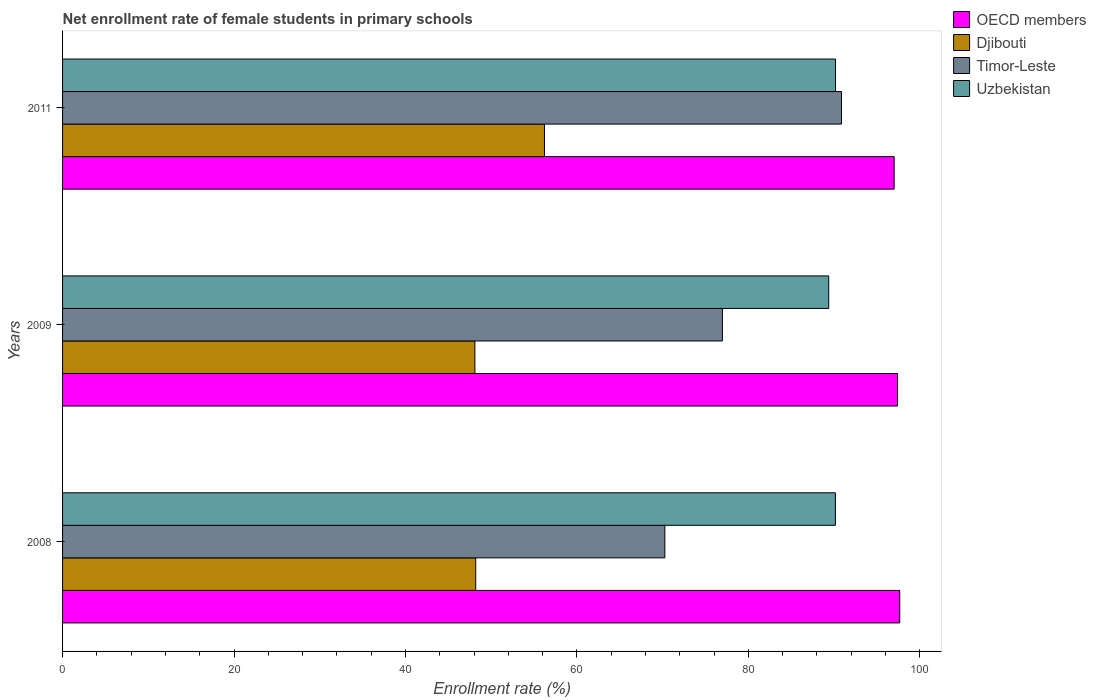How many groups of bars are there?
Provide a short and direct response. 3. Are the number of bars on each tick of the Y-axis equal?
Make the answer very short. Yes. How many bars are there on the 1st tick from the bottom?
Provide a short and direct response. 4. What is the net enrollment rate of female students in primary schools in Djibouti in 2011?
Your response must be concise. 56.22. Across all years, what is the maximum net enrollment rate of female students in primary schools in Timor-Leste?
Provide a succinct answer. 90.86. Across all years, what is the minimum net enrollment rate of female students in primary schools in Timor-Leste?
Keep it short and to the point. 70.26. What is the total net enrollment rate of female students in primary schools in Djibouti in the graph?
Offer a terse response. 152.51. What is the difference between the net enrollment rate of female students in primary schools in Djibouti in 2008 and that in 2011?
Make the answer very short. -8.02. What is the difference between the net enrollment rate of female students in primary schools in Timor-Leste in 2011 and the net enrollment rate of female students in primary schools in Djibouti in 2008?
Offer a terse response. 42.67. What is the average net enrollment rate of female students in primary schools in OECD members per year?
Provide a short and direct response. 97.36. In the year 2009, what is the difference between the net enrollment rate of female students in primary schools in Djibouti and net enrollment rate of female students in primary schools in Uzbekistan?
Give a very brief answer. -41.27. What is the ratio of the net enrollment rate of female students in primary schools in Uzbekistan in 2008 to that in 2009?
Ensure brevity in your answer.  1.01. What is the difference between the highest and the second highest net enrollment rate of female students in primary schools in OECD members?
Provide a succinct answer. 0.25. What is the difference between the highest and the lowest net enrollment rate of female students in primary schools in Djibouti?
Keep it short and to the point. 8.12. Is the sum of the net enrollment rate of female students in primary schools in OECD members in 2008 and 2011 greater than the maximum net enrollment rate of female students in primary schools in Djibouti across all years?
Your response must be concise. Yes. What does the 3rd bar from the top in 2008 represents?
Your answer should be very brief. Djibouti. What does the 3rd bar from the bottom in 2009 represents?
Provide a short and direct response. Timor-Leste. How many bars are there?
Your response must be concise. 12. What is the difference between two consecutive major ticks on the X-axis?
Make the answer very short. 20. Are the values on the major ticks of X-axis written in scientific E-notation?
Offer a terse response. No. Does the graph contain any zero values?
Make the answer very short. No. How are the legend labels stacked?
Your response must be concise. Vertical. What is the title of the graph?
Your response must be concise. Net enrollment rate of female students in primary schools. Does "East Asia (all income levels)" appear as one of the legend labels in the graph?
Provide a succinct answer. No. What is the label or title of the X-axis?
Your response must be concise. Enrollment rate (%). What is the label or title of the Y-axis?
Offer a very short reply. Years. What is the Enrollment rate (%) of OECD members in 2008?
Offer a very short reply. 97.66. What is the Enrollment rate (%) of Djibouti in 2008?
Give a very brief answer. 48.19. What is the Enrollment rate (%) in Timor-Leste in 2008?
Offer a very short reply. 70.26. What is the Enrollment rate (%) of Uzbekistan in 2008?
Offer a very short reply. 90.15. What is the Enrollment rate (%) in OECD members in 2009?
Offer a terse response. 97.4. What is the Enrollment rate (%) in Djibouti in 2009?
Offer a very short reply. 48.1. What is the Enrollment rate (%) in Timor-Leste in 2009?
Your answer should be compact. 76.97. What is the Enrollment rate (%) of Uzbekistan in 2009?
Your response must be concise. 89.37. What is the Enrollment rate (%) in OECD members in 2011?
Your answer should be very brief. 97.01. What is the Enrollment rate (%) of Djibouti in 2011?
Your answer should be very brief. 56.22. What is the Enrollment rate (%) in Timor-Leste in 2011?
Offer a very short reply. 90.86. What is the Enrollment rate (%) of Uzbekistan in 2011?
Provide a short and direct response. 90.17. Across all years, what is the maximum Enrollment rate (%) of OECD members?
Your response must be concise. 97.66. Across all years, what is the maximum Enrollment rate (%) of Djibouti?
Provide a short and direct response. 56.22. Across all years, what is the maximum Enrollment rate (%) in Timor-Leste?
Your answer should be compact. 90.86. Across all years, what is the maximum Enrollment rate (%) of Uzbekistan?
Your answer should be compact. 90.17. Across all years, what is the minimum Enrollment rate (%) of OECD members?
Offer a terse response. 97.01. Across all years, what is the minimum Enrollment rate (%) in Djibouti?
Make the answer very short. 48.1. Across all years, what is the minimum Enrollment rate (%) of Timor-Leste?
Your answer should be very brief. 70.26. Across all years, what is the minimum Enrollment rate (%) in Uzbekistan?
Provide a short and direct response. 89.37. What is the total Enrollment rate (%) in OECD members in the graph?
Offer a terse response. 292.07. What is the total Enrollment rate (%) of Djibouti in the graph?
Your answer should be compact. 152.51. What is the total Enrollment rate (%) in Timor-Leste in the graph?
Provide a short and direct response. 238.09. What is the total Enrollment rate (%) in Uzbekistan in the graph?
Provide a succinct answer. 269.69. What is the difference between the Enrollment rate (%) of OECD members in 2008 and that in 2009?
Your response must be concise. 0.25. What is the difference between the Enrollment rate (%) of Djibouti in 2008 and that in 2009?
Your answer should be very brief. 0.1. What is the difference between the Enrollment rate (%) in Timor-Leste in 2008 and that in 2009?
Your response must be concise. -6.71. What is the difference between the Enrollment rate (%) in Uzbekistan in 2008 and that in 2009?
Provide a short and direct response. 0.78. What is the difference between the Enrollment rate (%) of OECD members in 2008 and that in 2011?
Give a very brief answer. 0.65. What is the difference between the Enrollment rate (%) of Djibouti in 2008 and that in 2011?
Provide a short and direct response. -8.02. What is the difference between the Enrollment rate (%) of Timor-Leste in 2008 and that in 2011?
Your answer should be compact. -20.61. What is the difference between the Enrollment rate (%) in Uzbekistan in 2008 and that in 2011?
Offer a terse response. -0.01. What is the difference between the Enrollment rate (%) of OECD members in 2009 and that in 2011?
Make the answer very short. 0.4. What is the difference between the Enrollment rate (%) in Djibouti in 2009 and that in 2011?
Offer a very short reply. -8.12. What is the difference between the Enrollment rate (%) of Timor-Leste in 2009 and that in 2011?
Provide a succinct answer. -13.89. What is the difference between the Enrollment rate (%) of Uzbekistan in 2009 and that in 2011?
Ensure brevity in your answer.  -0.79. What is the difference between the Enrollment rate (%) in OECD members in 2008 and the Enrollment rate (%) in Djibouti in 2009?
Your response must be concise. 49.56. What is the difference between the Enrollment rate (%) of OECD members in 2008 and the Enrollment rate (%) of Timor-Leste in 2009?
Provide a succinct answer. 20.68. What is the difference between the Enrollment rate (%) of OECD members in 2008 and the Enrollment rate (%) of Uzbekistan in 2009?
Ensure brevity in your answer.  8.28. What is the difference between the Enrollment rate (%) in Djibouti in 2008 and the Enrollment rate (%) in Timor-Leste in 2009?
Give a very brief answer. -28.78. What is the difference between the Enrollment rate (%) of Djibouti in 2008 and the Enrollment rate (%) of Uzbekistan in 2009?
Provide a short and direct response. -41.18. What is the difference between the Enrollment rate (%) in Timor-Leste in 2008 and the Enrollment rate (%) in Uzbekistan in 2009?
Make the answer very short. -19.11. What is the difference between the Enrollment rate (%) in OECD members in 2008 and the Enrollment rate (%) in Djibouti in 2011?
Make the answer very short. 41.44. What is the difference between the Enrollment rate (%) of OECD members in 2008 and the Enrollment rate (%) of Timor-Leste in 2011?
Make the answer very short. 6.79. What is the difference between the Enrollment rate (%) in OECD members in 2008 and the Enrollment rate (%) in Uzbekistan in 2011?
Offer a very short reply. 7.49. What is the difference between the Enrollment rate (%) in Djibouti in 2008 and the Enrollment rate (%) in Timor-Leste in 2011?
Make the answer very short. -42.67. What is the difference between the Enrollment rate (%) in Djibouti in 2008 and the Enrollment rate (%) in Uzbekistan in 2011?
Offer a terse response. -41.97. What is the difference between the Enrollment rate (%) in Timor-Leste in 2008 and the Enrollment rate (%) in Uzbekistan in 2011?
Offer a terse response. -19.91. What is the difference between the Enrollment rate (%) of OECD members in 2009 and the Enrollment rate (%) of Djibouti in 2011?
Keep it short and to the point. 41.19. What is the difference between the Enrollment rate (%) in OECD members in 2009 and the Enrollment rate (%) in Timor-Leste in 2011?
Ensure brevity in your answer.  6.54. What is the difference between the Enrollment rate (%) in OECD members in 2009 and the Enrollment rate (%) in Uzbekistan in 2011?
Ensure brevity in your answer.  7.24. What is the difference between the Enrollment rate (%) of Djibouti in 2009 and the Enrollment rate (%) of Timor-Leste in 2011?
Your answer should be compact. -42.77. What is the difference between the Enrollment rate (%) in Djibouti in 2009 and the Enrollment rate (%) in Uzbekistan in 2011?
Your answer should be compact. -42.07. What is the difference between the Enrollment rate (%) of Timor-Leste in 2009 and the Enrollment rate (%) of Uzbekistan in 2011?
Provide a short and direct response. -13.19. What is the average Enrollment rate (%) of OECD members per year?
Give a very brief answer. 97.36. What is the average Enrollment rate (%) of Djibouti per year?
Your response must be concise. 50.84. What is the average Enrollment rate (%) of Timor-Leste per year?
Provide a short and direct response. 79.36. What is the average Enrollment rate (%) in Uzbekistan per year?
Offer a very short reply. 89.9. In the year 2008, what is the difference between the Enrollment rate (%) of OECD members and Enrollment rate (%) of Djibouti?
Ensure brevity in your answer.  49.46. In the year 2008, what is the difference between the Enrollment rate (%) of OECD members and Enrollment rate (%) of Timor-Leste?
Your answer should be very brief. 27.4. In the year 2008, what is the difference between the Enrollment rate (%) of OECD members and Enrollment rate (%) of Uzbekistan?
Ensure brevity in your answer.  7.5. In the year 2008, what is the difference between the Enrollment rate (%) of Djibouti and Enrollment rate (%) of Timor-Leste?
Your answer should be compact. -22.06. In the year 2008, what is the difference between the Enrollment rate (%) of Djibouti and Enrollment rate (%) of Uzbekistan?
Provide a short and direct response. -41.96. In the year 2008, what is the difference between the Enrollment rate (%) of Timor-Leste and Enrollment rate (%) of Uzbekistan?
Give a very brief answer. -19.89. In the year 2009, what is the difference between the Enrollment rate (%) of OECD members and Enrollment rate (%) of Djibouti?
Make the answer very short. 49.3. In the year 2009, what is the difference between the Enrollment rate (%) in OECD members and Enrollment rate (%) in Timor-Leste?
Provide a succinct answer. 20.43. In the year 2009, what is the difference between the Enrollment rate (%) of OECD members and Enrollment rate (%) of Uzbekistan?
Provide a succinct answer. 8.03. In the year 2009, what is the difference between the Enrollment rate (%) of Djibouti and Enrollment rate (%) of Timor-Leste?
Offer a terse response. -28.87. In the year 2009, what is the difference between the Enrollment rate (%) in Djibouti and Enrollment rate (%) in Uzbekistan?
Your answer should be very brief. -41.27. In the year 2009, what is the difference between the Enrollment rate (%) of Timor-Leste and Enrollment rate (%) of Uzbekistan?
Your answer should be compact. -12.4. In the year 2011, what is the difference between the Enrollment rate (%) in OECD members and Enrollment rate (%) in Djibouti?
Your answer should be compact. 40.79. In the year 2011, what is the difference between the Enrollment rate (%) of OECD members and Enrollment rate (%) of Timor-Leste?
Provide a succinct answer. 6.14. In the year 2011, what is the difference between the Enrollment rate (%) in OECD members and Enrollment rate (%) in Uzbekistan?
Ensure brevity in your answer.  6.84. In the year 2011, what is the difference between the Enrollment rate (%) in Djibouti and Enrollment rate (%) in Timor-Leste?
Offer a very short reply. -34.65. In the year 2011, what is the difference between the Enrollment rate (%) in Djibouti and Enrollment rate (%) in Uzbekistan?
Make the answer very short. -33.95. In the year 2011, what is the difference between the Enrollment rate (%) in Timor-Leste and Enrollment rate (%) in Uzbekistan?
Keep it short and to the point. 0.7. What is the ratio of the Enrollment rate (%) in OECD members in 2008 to that in 2009?
Provide a succinct answer. 1. What is the ratio of the Enrollment rate (%) in Djibouti in 2008 to that in 2009?
Your answer should be compact. 1. What is the ratio of the Enrollment rate (%) in Timor-Leste in 2008 to that in 2009?
Offer a very short reply. 0.91. What is the ratio of the Enrollment rate (%) in Uzbekistan in 2008 to that in 2009?
Your response must be concise. 1.01. What is the ratio of the Enrollment rate (%) of OECD members in 2008 to that in 2011?
Keep it short and to the point. 1.01. What is the ratio of the Enrollment rate (%) in Djibouti in 2008 to that in 2011?
Keep it short and to the point. 0.86. What is the ratio of the Enrollment rate (%) of Timor-Leste in 2008 to that in 2011?
Ensure brevity in your answer.  0.77. What is the ratio of the Enrollment rate (%) in Uzbekistan in 2008 to that in 2011?
Give a very brief answer. 1. What is the ratio of the Enrollment rate (%) in OECD members in 2009 to that in 2011?
Offer a very short reply. 1. What is the ratio of the Enrollment rate (%) of Djibouti in 2009 to that in 2011?
Offer a very short reply. 0.86. What is the ratio of the Enrollment rate (%) of Timor-Leste in 2009 to that in 2011?
Provide a short and direct response. 0.85. What is the ratio of the Enrollment rate (%) in Uzbekistan in 2009 to that in 2011?
Your answer should be very brief. 0.99. What is the difference between the highest and the second highest Enrollment rate (%) in OECD members?
Give a very brief answer. 0.25. What is the difference between the highest and the second highest Enrollment rate (%) of Djibouti?
Ensure brevity in your answer.  8.02. What is the difference between the highest and the second highest Enrollment rate (%) in Timor-Leste?
Ensure brevity in your answer.  13.89. What is the difference between the highest and the second highest Enrollment rate (%) of Uzbekistan?
Your response must be concise. 0.01. What is the difference between the highest and the lowest Enrollment rate (%) of OECD members?
Provide a short and direct response. 0.65. What is the difference between the highest and the lowest Enrollment rate (%) of Djibouti?
Ensure brevity in your answer.  8.12. What is the difference between the highest and the lowest Enrollment rate (%) of Timor-Leste?
Offer a terse response. 20.61. What is the difference between the highest and the lowest Enrollment rate (%) of Uzbekistan?
Your answer should be very brief. 0.79. 